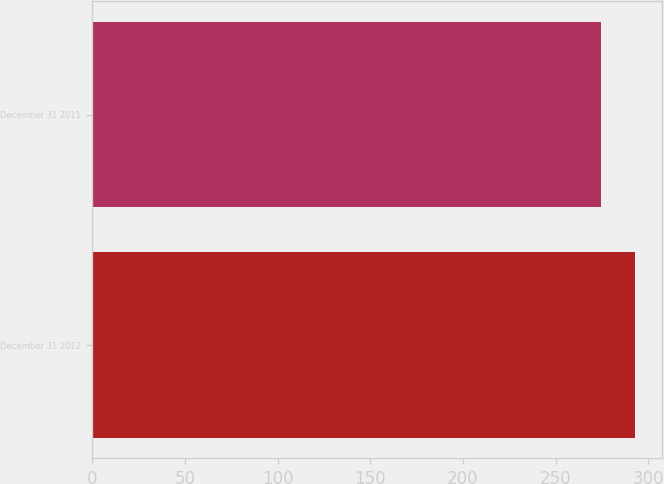Convert chart to OTSL. <chart><loc_0><loc_0><loc_500><loc_500><bar_chart><fcel>December 31 2012<fcel>December 31 2011<nl><fcel>292.6<fcel>274.6<nl></chart> 